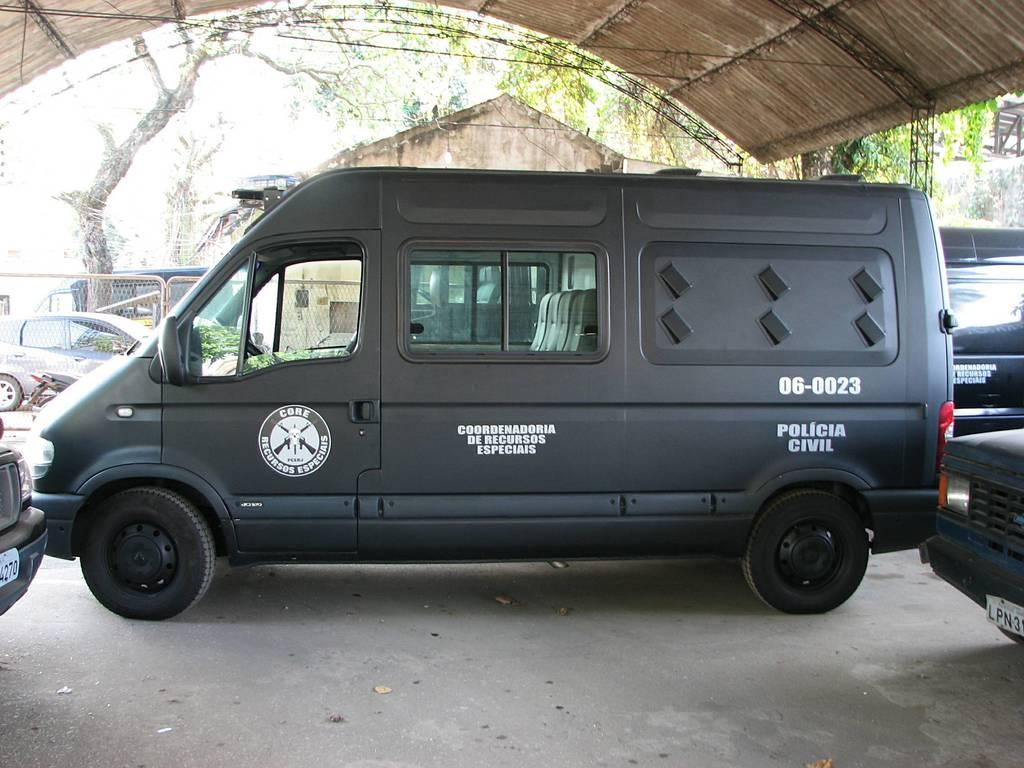<image>
Share a concise interpretation of the image provided. A black van says core recursos especiais on the driver's door. 